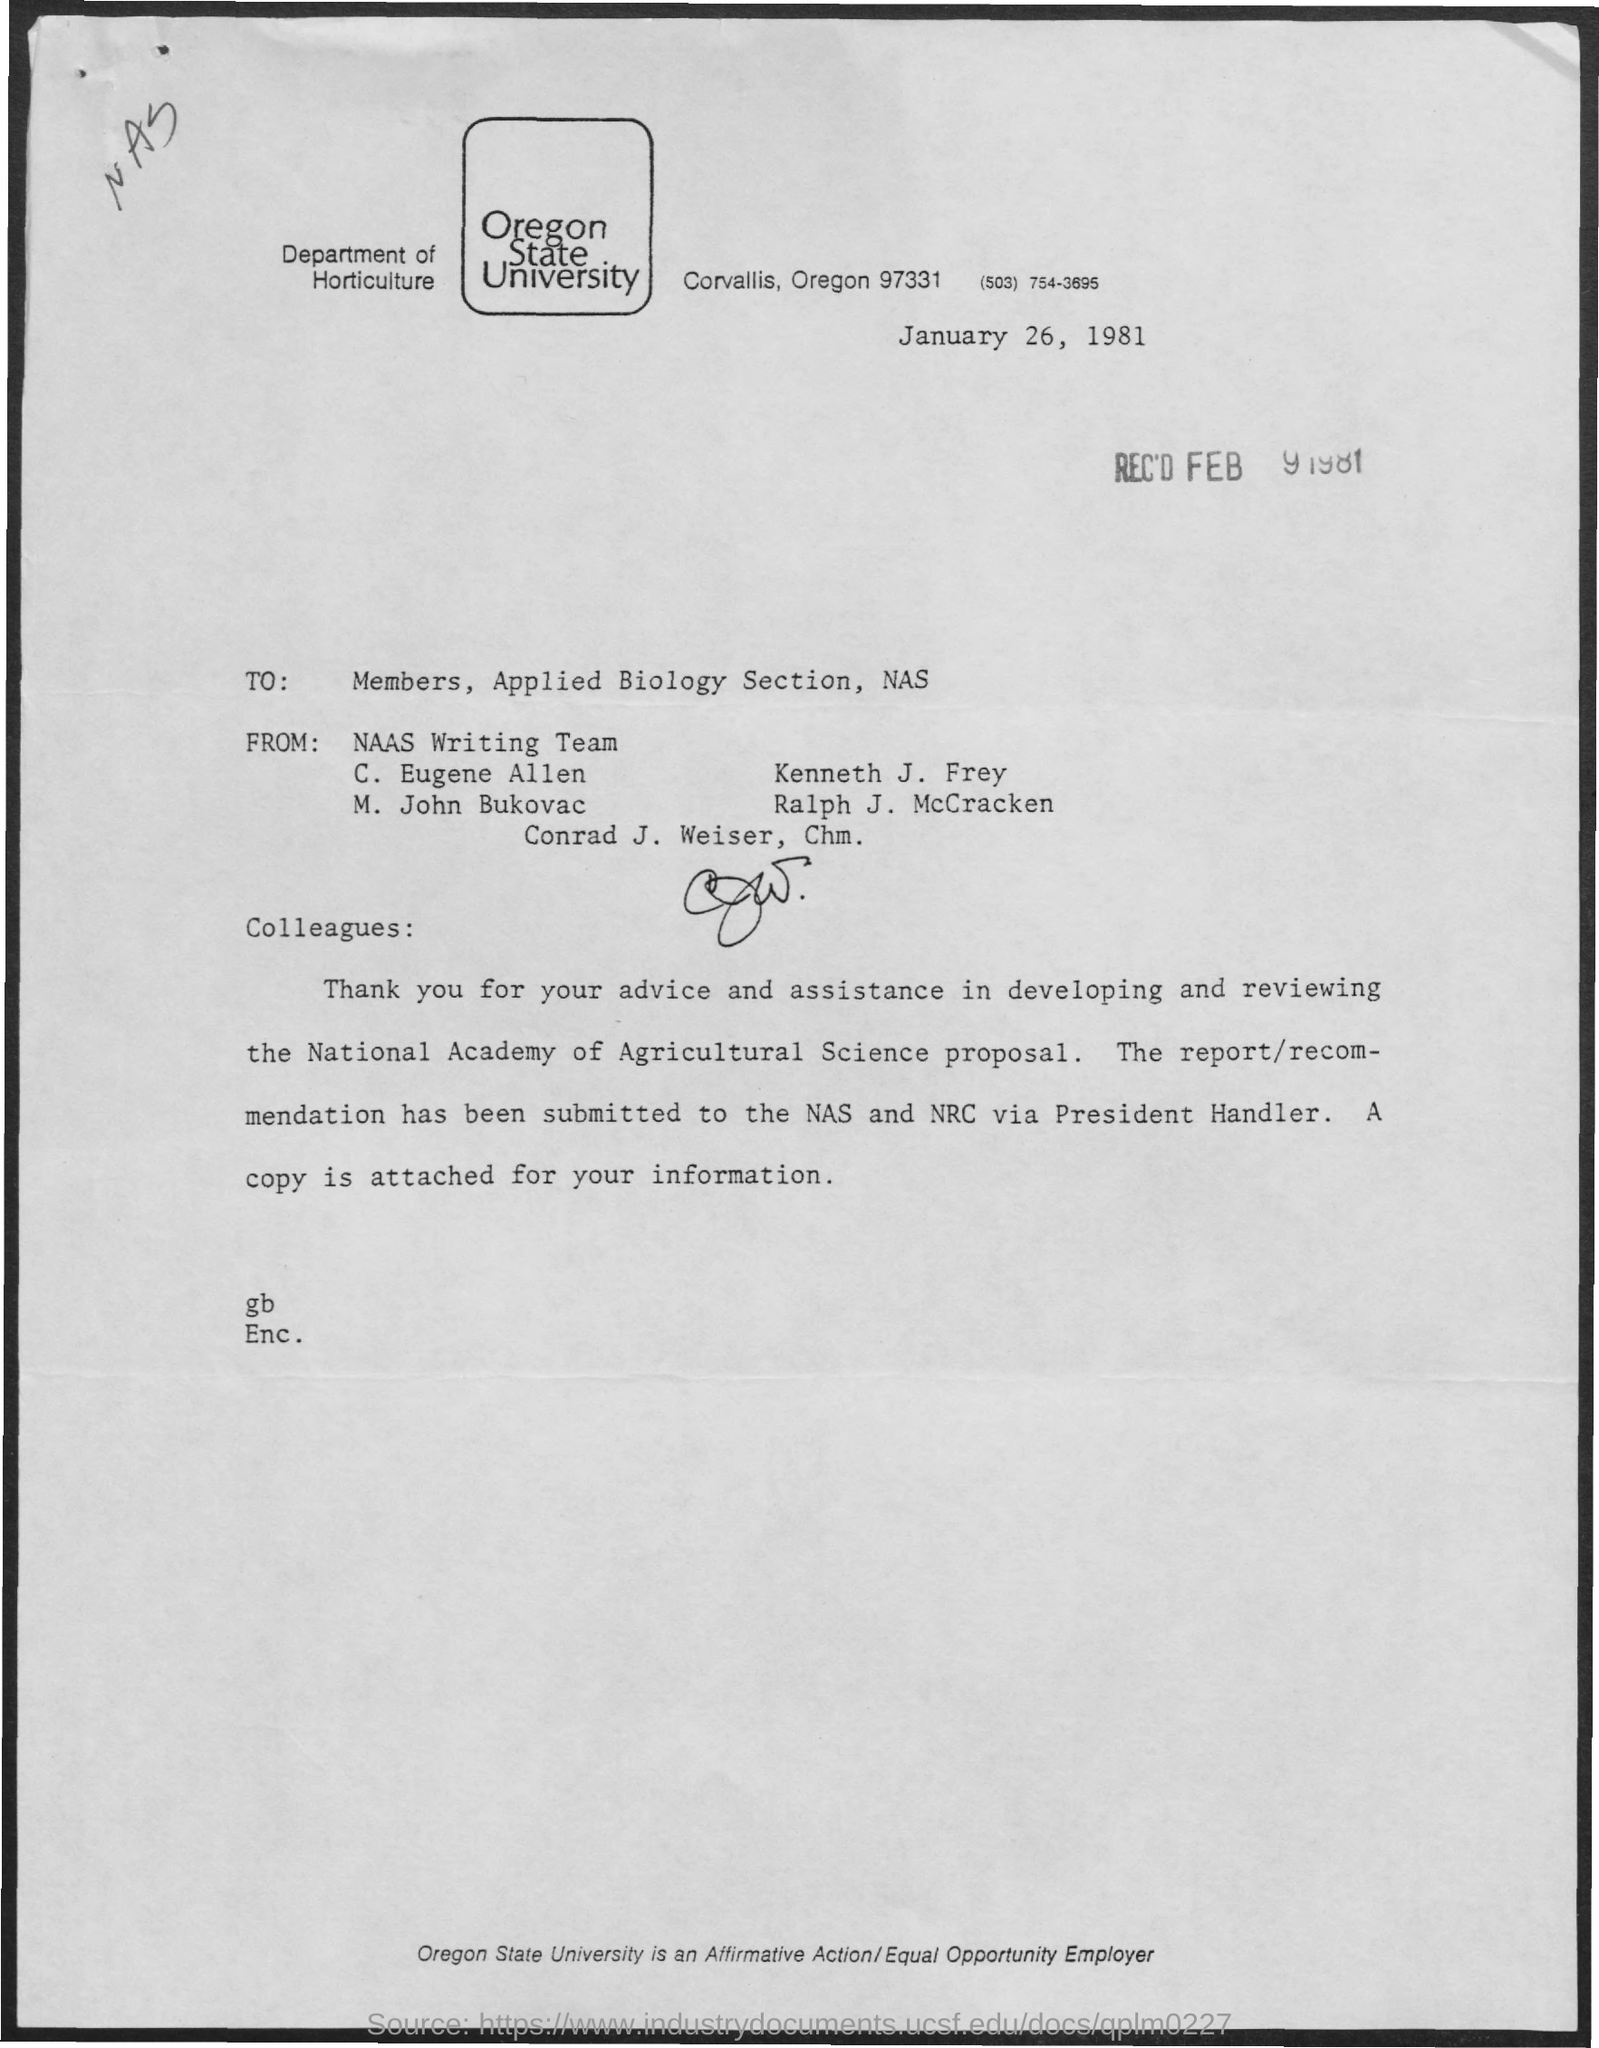What is the name of the university mentioned in the given letter ?
Ensure brevity in your answer.  OREGON STATE UNIVERSITY. On which date this letter was written ?
Your response must be concise. January 26 , 1981. What is  the name of the department mentioned in the given letter ?
Give a very brief answer. DEPARTMENT OF HORTICULTURE. On which date this letter was received ?
Give a very brief answer. Feb 9 , 1981. To whom this letter was written ?
Your answer should be compact. MEMBERS, APPLIED BIOLOGY SECTION, NAS. From whom this letter was delivered ?
Offer a very short reply. NAAS writing team. 